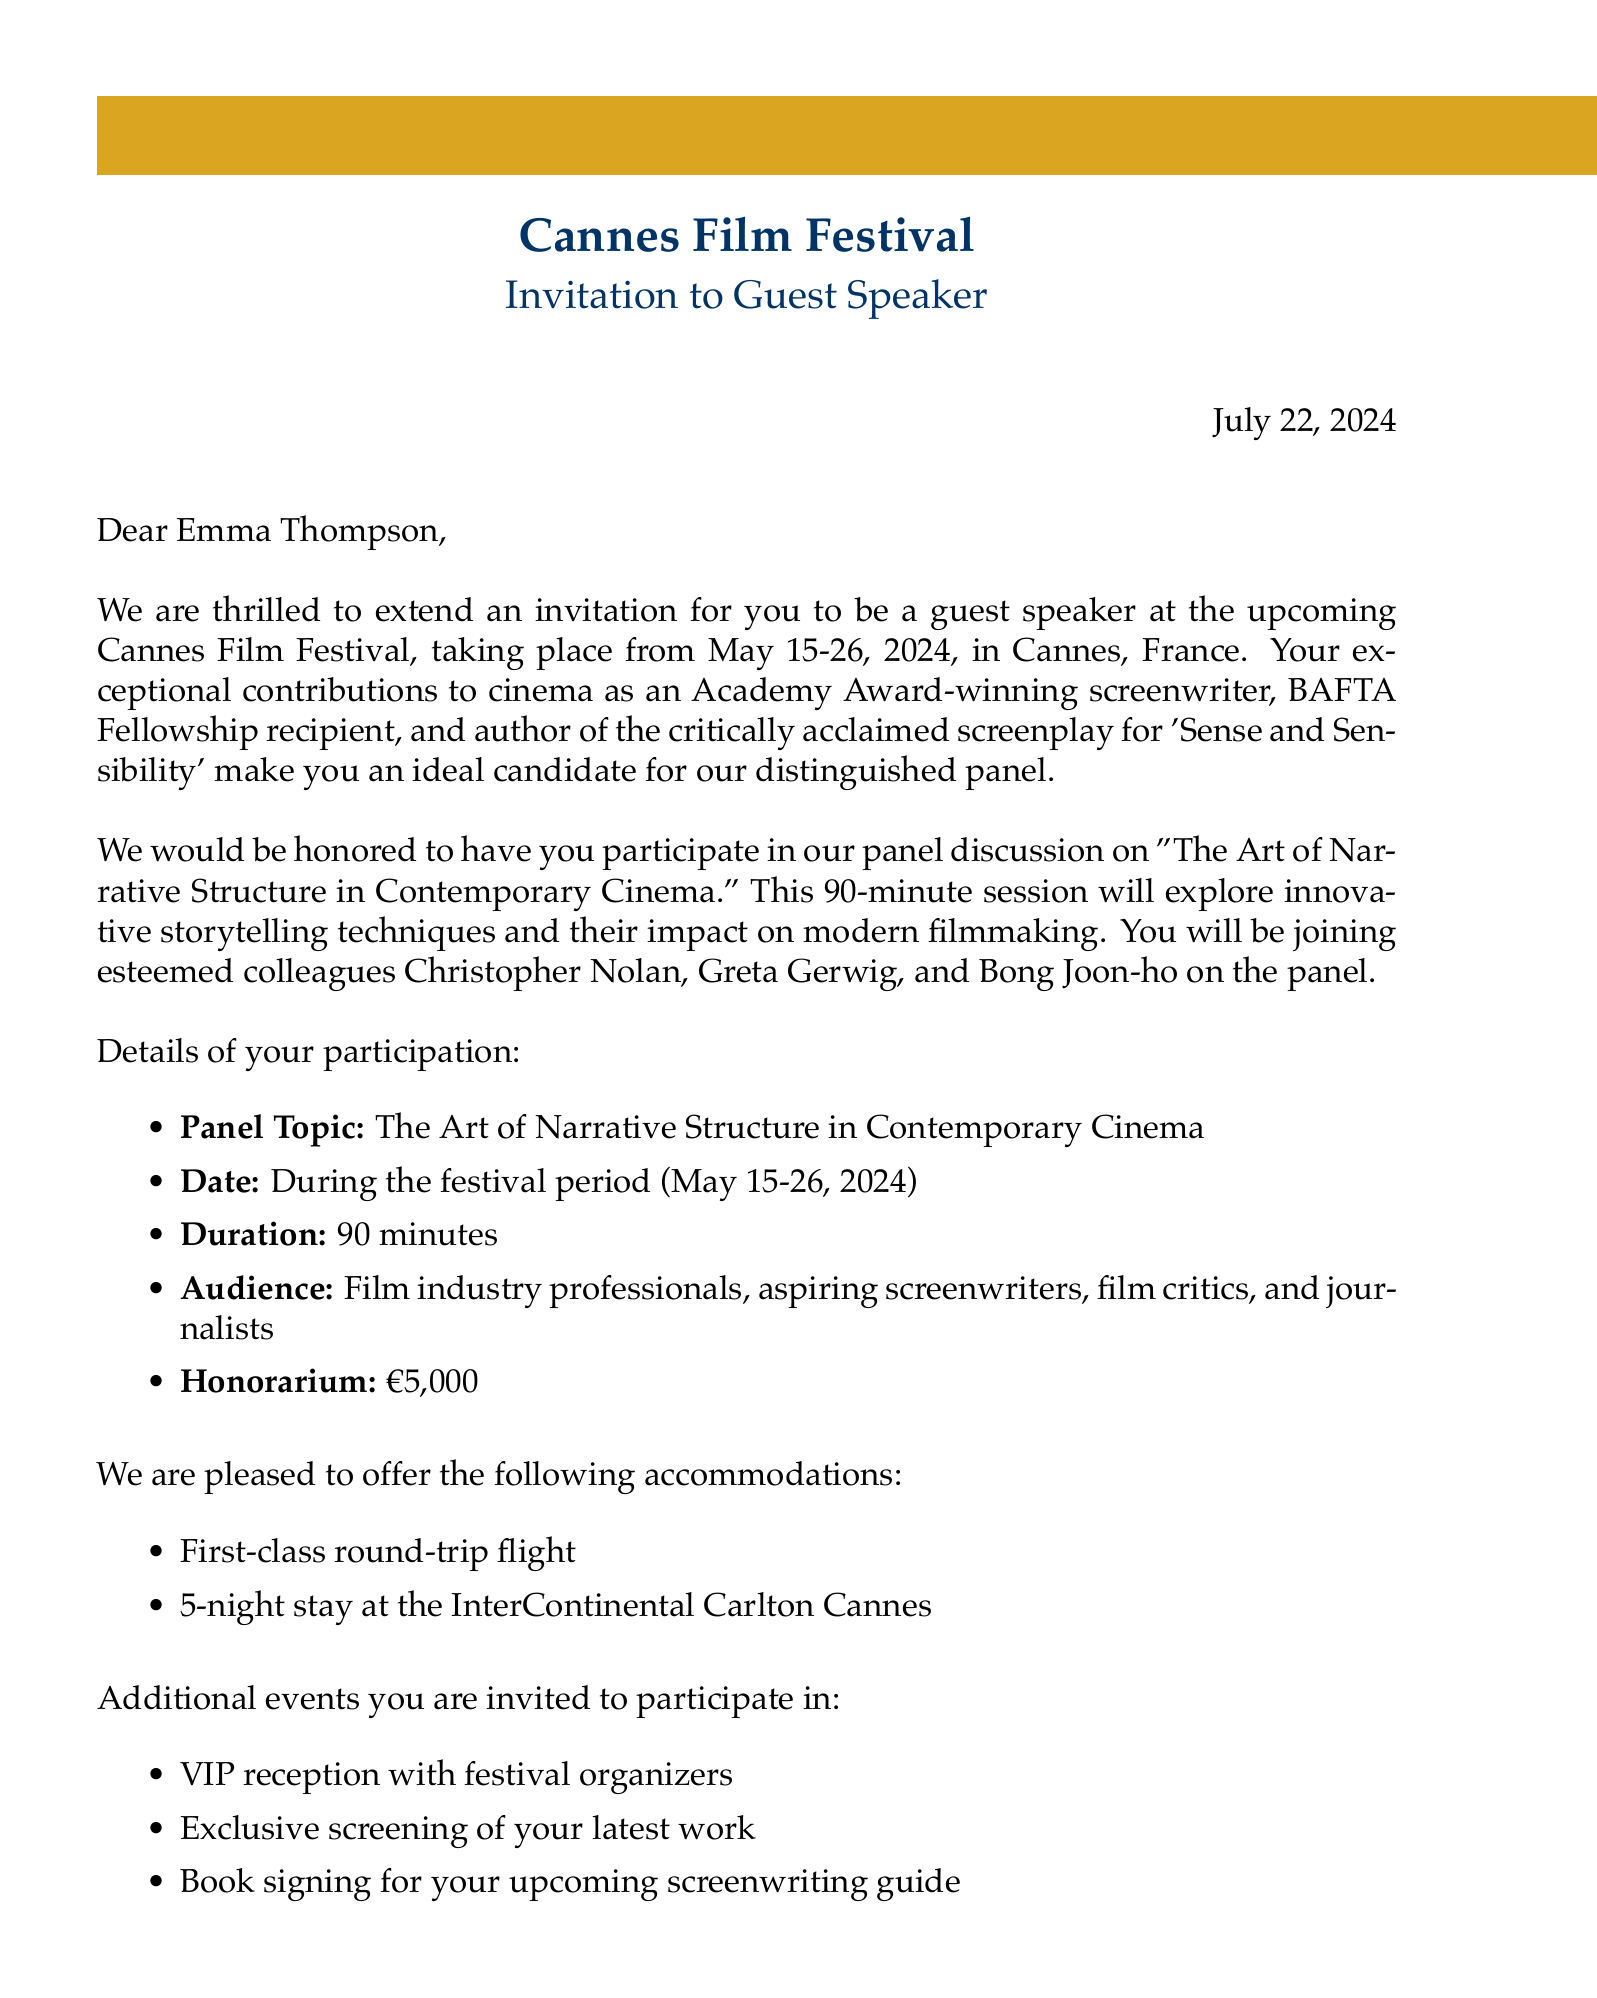What is the name of the festival? The festival name is mentioned prominently in the document as the Cannes Film Festival.
Answer: Cannes Film Festival What are the dates of the event? The document specifies the event dates as May 15-26, 2024.
Answer: May 15-26, 2024 Who is the contact person for this invitation? The document lists Sophie Marceau as the Head of Programming and the contact person.
Answer: Sophie Marceau What is the panel topic? The panel topic is clearly stated as "The Art of Narrative Structure in Contemporary Cinema."
Answer: The Art of Narrative Structure in Contemporary Cinema How long is the speaking duration? The document specifies the duration of the speaking session as 90 minutes.
Answer: 90 minutes What is the honorarium for the guest speaker? The honorarium mentioned in the document is €5,000.
Answer: €5,000 How many nights will the hotel stay be? The hotel accommodation provided is for a 5-night stay.
Answer: 5-night stay What is one of the special requests made for the speaker? One special request is for the speaker to prepare a 15-minute presentation on narrative arcs.
Answer: 15-minute presentation on narrative arcs Who are the other panelists? The document lists Christopher Nolan, Greta Gerwig, and Bong Joon-ho as other panelists.
Answer: Christopher Nolan, Greta Gerwig, Bong Joon-ho 